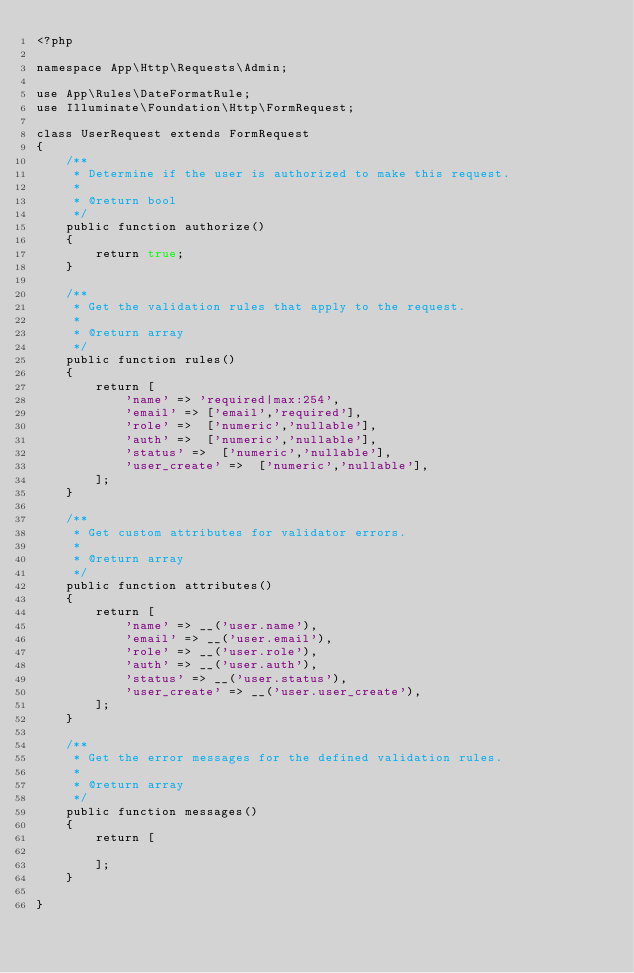<code> <loc_0><loc_0><loc_500><loc_500><_PHP_><?php

namespace App\Http\Requests\Admin;

use App\Rules\DateFormatRule;
use Illuminate\Foundation\Http\FormRequest;

class UserRequest extends FormRequest
{
    /**
     * Determine if the user is authorized to make this request.
     *
     * @return bool
     */
    public function authorize()
    {
        return true;
    }

    /**
     * Get the validation rules that apply to the request.
     *
     * @return array
     */
    public function rules()
    {
        return [
            'name' => 'required|max:254',
            'email' => ['email','required'],
            'role' =>  ['numeric','nullable'],
            'auth' =>  ['numeric','nullable'],
            'status' =>  ['numeric','nullable'],
            'user_create' =>  ['numeric','nullable'],
        ];
    }

    /**
     * Get custom attributes for validator errors.
     *
     * @return array
     */
    public function attributes()
    {
        return [
            'name' => __('user.name'),
            'email' => __('user.email'),
            'role' => __('user.role'),
            'auth' => __('user.auth'),
            'status' => __('user.status'),
            'user_create' => __('user.user_create'),
        ];
    }

    /**
     * Get the error messages for the defined validation rules.
     *
     * @return array
     */
    public function messages()
    {
        return [

        ];
    }

}
</code> 